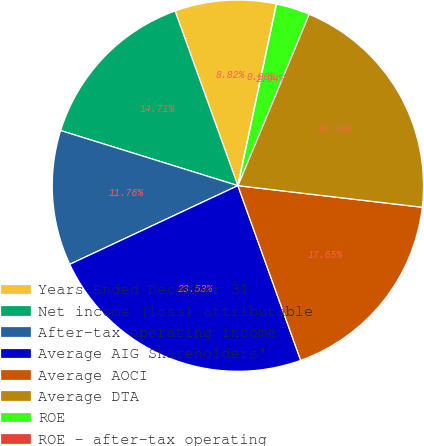Convert chart to OTSL. <chart><loc_0><loc_0><loc_500><loc_500><pie_chart><fcel>Years Ended December 31<fcel>Net income (loss) attributable<fcel>After-tax operating income<fcel>Average AIG Shareholders'<fcel>Average AOCI<fcel>Average DTA<fcel>ROE<fcel>ROE - after-tax operating<nl><fcel>8.82%<fcel>14.71%<fcel>11.76%<fcel>23.53%<fcel>17.65%<fcel>20.59%<fcel>2.94%<fcel>0.0%<nl></chart> 